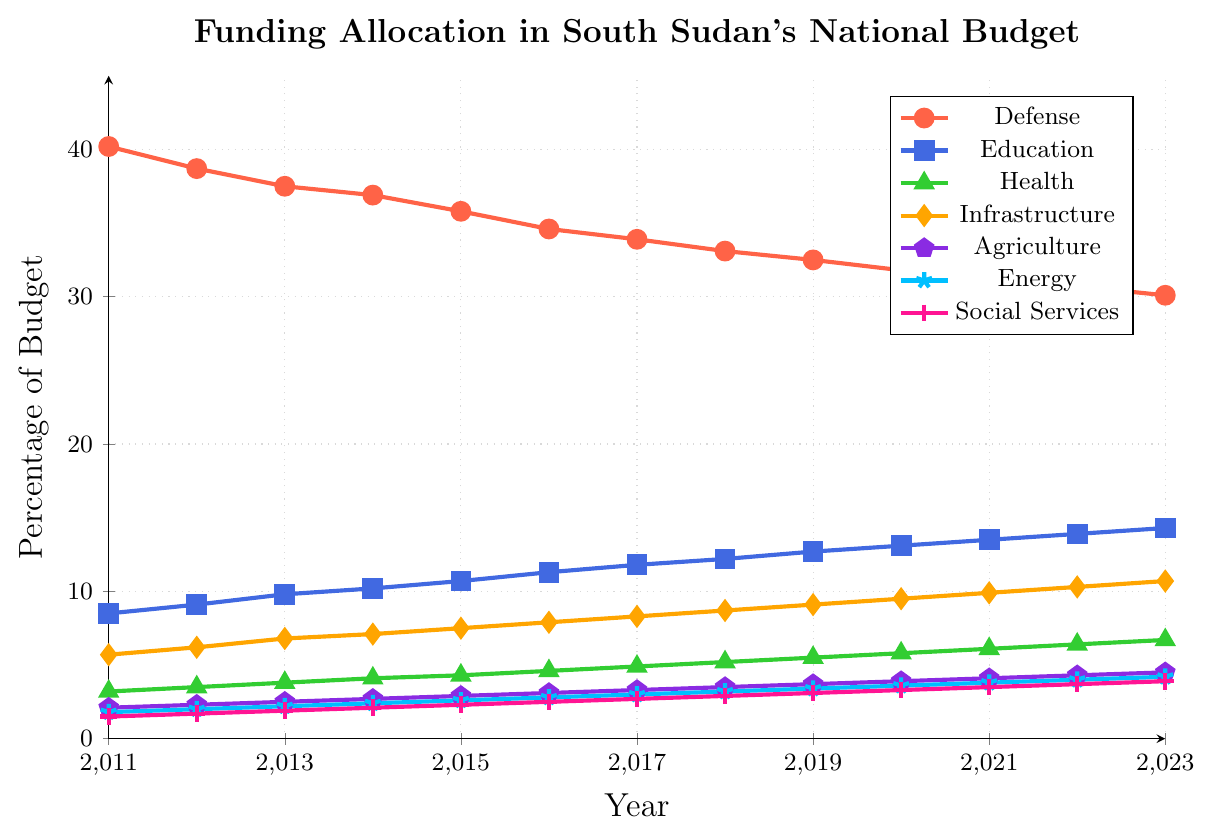How has the allocation for the Defense sector changed from 2011 to 2023? To determine how the allocation for Defense has changed, observe the line for Defense marked in red. The percentage has steadily decreased from 40.2% in 2011 to 30.1% in 2023.
Answer: The allocation has decreased Which sector has seen the highest increase in its budget allocation from 2011 to 2023? Compare the starting and ending values of all sectors. Education starts at 8.5% in 2011 and ends at 14.3% in 2023, leading to an increase of 5.8%. This is the highest increase compared to other sectors.
Answer: Education What is the difference in budget allocation between Infrastructure and Agriculture in 2023? Look at the values for Infrastructure and Agriculture in 2023. Infrastructure is at 10.7%, and Agriculture is at 4.5%. The difference is 10.7% - 4.5% = 6.2%.
Answer: 6.2% What is the average budget allocation for Health over the period from 2011 to 2023? Sum the Health allocations from 2011 to 2023 and divide by the number of years. Total is (3.2+3.5+3.8+4.1+4.3+4.6+4.9+5.2+5.5+5.8+6.1+6.4+6.7) = 63.1. There are 13 years, so the average is 63.1/13 🡨 4.85%.
Answer: 4.85% Which year had the widest disparity between the highest and lowest budget allocations among all sectors? Calculate the disparity (difference) between the highest and lowest values for each year. For 2011, the disparity is 40.2% (Defense) - 1.5% (Social Services) = 38.7%. Repeat the calculation for each year and find which year has the widest disparity.
Answer: 2011 When did the allocation for Education surpass 10%, and what was the allocation for Defense that year? Identify the first year where Education's allocation is greater than 10%. This occurs in 2014 with 10.2%. The Defense allocation in that year was 36.9%.
Answer: 2014; 36.9% How did the budget allocation for Energy change between 2011 and 2023 and what is the total increase over these years? Observe the values for the Energy sector. It starts at 1.8% in 2011 and ends at 4.2% in 2023. The total increase is 4.2% - 1.8% = 2.4%.
Answer: It increased by 2.4% Which sector has consistently increased its allocation every year from 2011 to 2023? Examine each sector's line to determine if the allocation increases every consecutive year. Education shows a consistent increase every year from 8.5% in 2011 to 14.3% in 2023.
Answer: Education Compare the trends for Agriculture and Social Services allocations from 2011 to 2023. Both sectors show an upward trend. Agriculture increases from 2.1% in 2011 to 4.5% in 2023, while Social Services increase from 1.5% in 2011 to 3.9% in 2023.
Answer: Both have increased In which year was the budget allocation for Health closest to 5%? Look at the values for Health and find the year when it is closest to 5%. In 2018, the allocation is 5.2%, which is closest to 5.0%.
Answer: 2018 